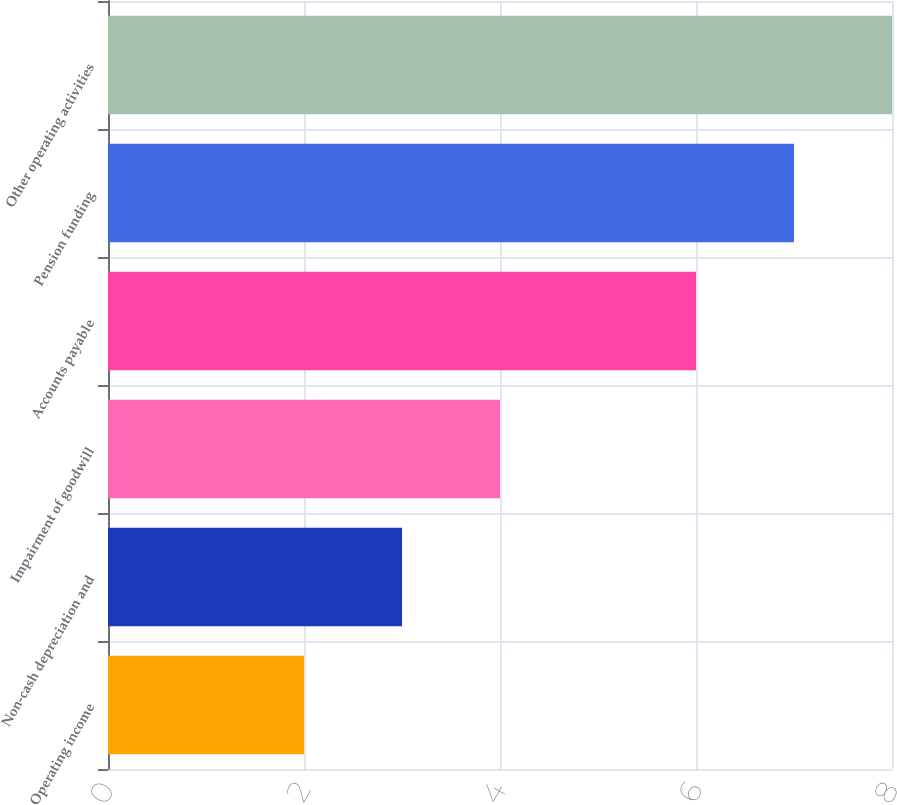Convert chart to OTSL. <chart><loc_0><loc_0><loc_500><loc_500><bar_chart><fcel>Operating income<fcel>Non-cash depreciation and<fcel>Impairment of goodwill<fcel>Accounts payable<fcel>Pension funding<fcel>Other operating activities<nl><fcel>2<fcel>3<fcel>4<fcel>6<fcel>7<fcel>8<nl></chart> 